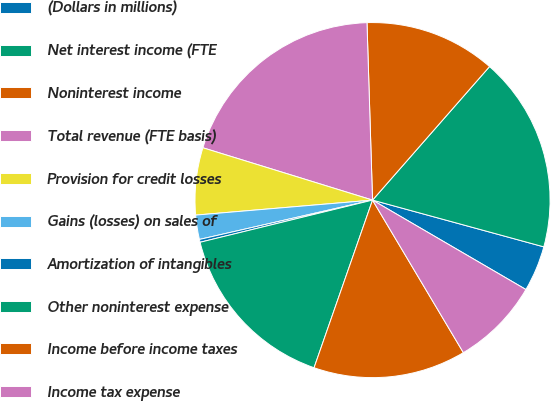Convert chart. <chart><loc_0><loc_0><loc_500><loc_500><pie_chart><fcel>(Dollars in millions)<fcel>Net interest income (FTE<fcel>Noninterest income<fcel>Total revenue (FTE basis)<fcel>Provision for credit losses<fcel>Gains (losses) on sales of<fcel>Amortization of intangibles<fcel>Other noninterest expense<fcel>Income before income taxes<fcel>Income tax expense<nl><fcel>4.16%<fcel>17.79%<fcel>11.95%<fcel>19.74%<fcel>6.11%<fcel>2.21%<fcel>0.26%<fcel>15.84%<fcel>13.89%<fcel>8.05%<nl></chart> 